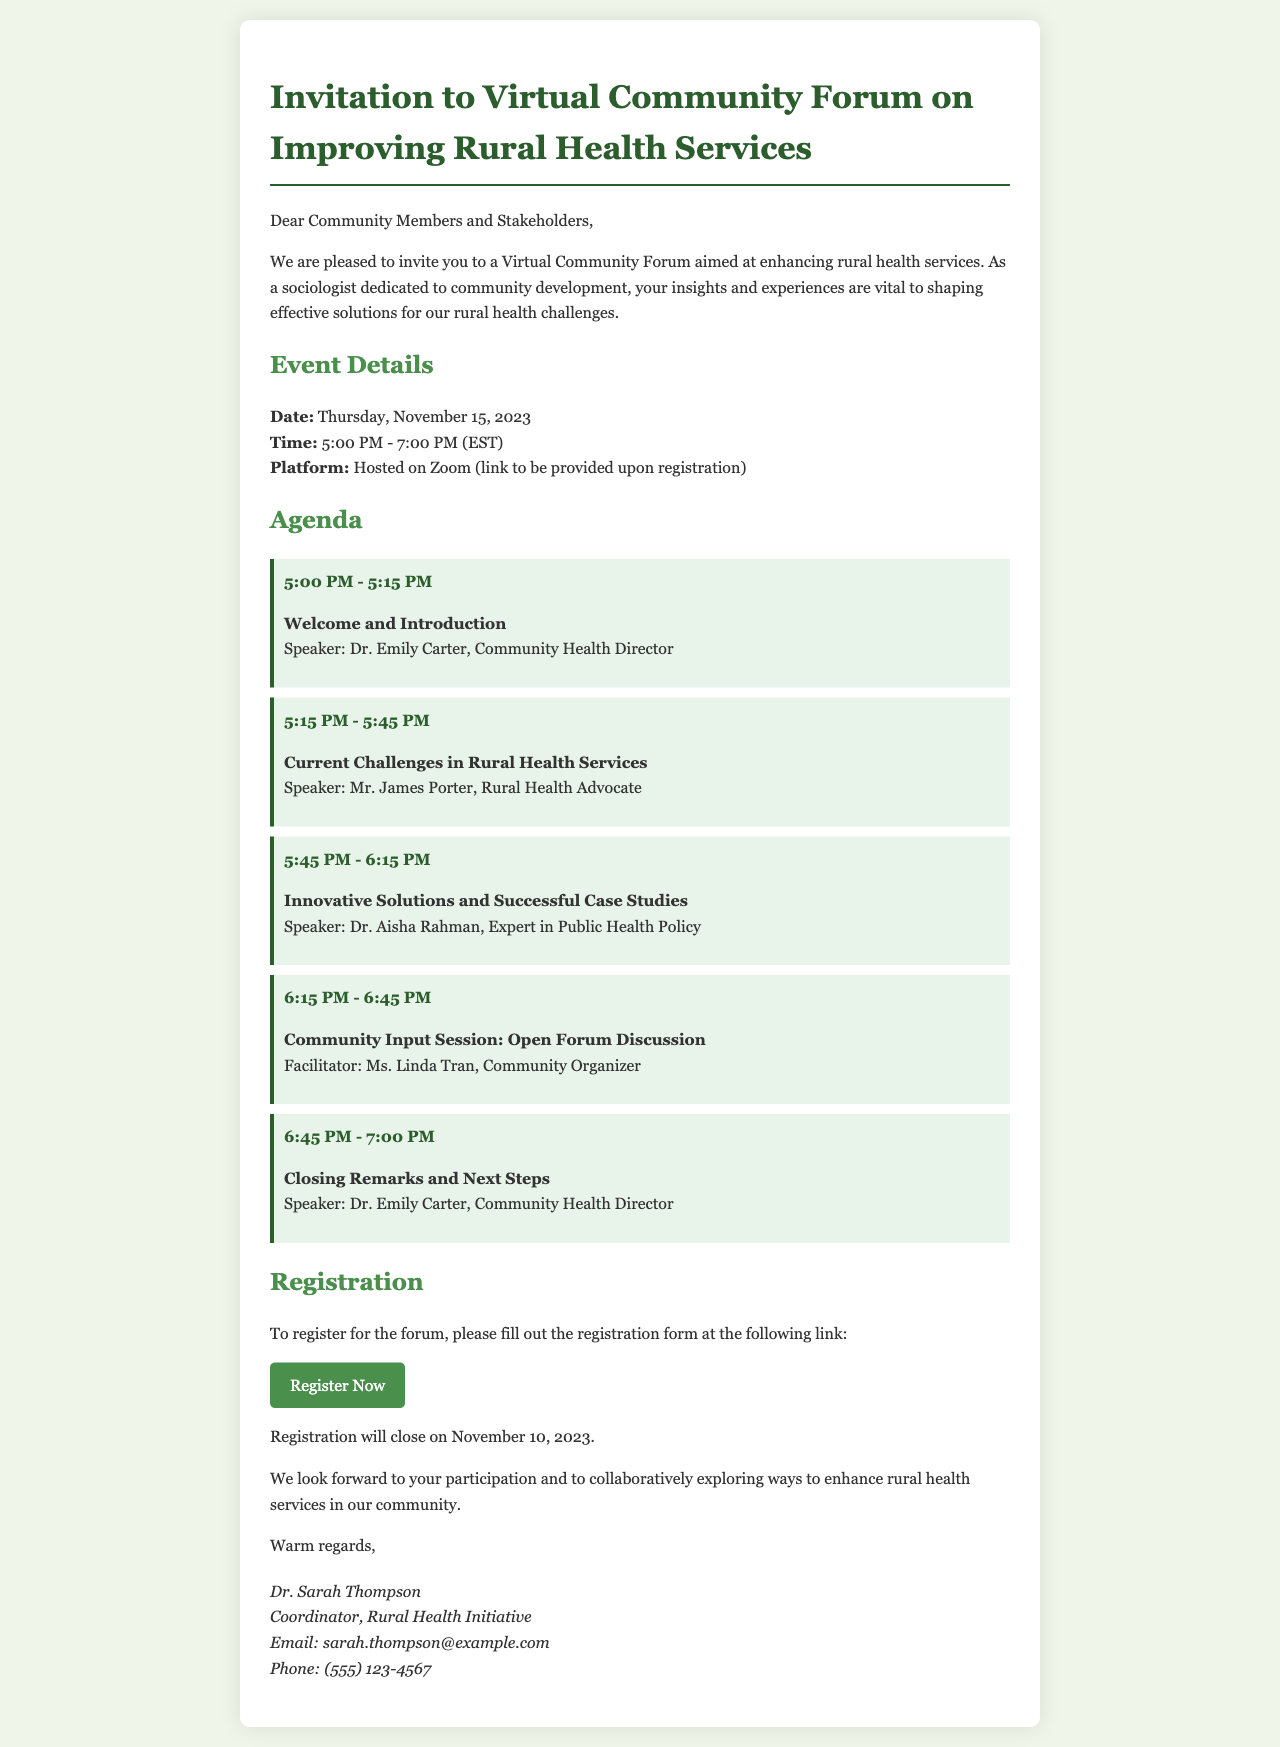What is the date of the virtual community forum? The date of the forum is mentioned clearly in the document as Thursday, November 15, 2023.
Answer: Thursday, November 15, 2023 What time does the forum start? The start time of the forum is specified as 5:00 PM in the event details section.
Answer: 5:00 PM Who is the speaker for the closing remarks? The document lists Dr. Emily Carter as the speaker for the closing remarks section.
Answer: Dr. Emily Carter What is the last date for registration? The registration closing date is explicitly stated as November 10, 2023.
Answer: November 10, 2023 What platform will the forum be hosted on? The platform for the forum is mentioned as Zoom in the event details.
Answer: Zoom What is the total duration of the forum? The forum runs from 5:00 PM to 7:00 PM, which is a total of 2 hours.
Answer: 2 hours What topic is discussed from 5:15 PM to 5:45 PM? This time slot covers "Current Challenges in Rural Health Services," as indicated in the agenda.
Answer: Current Challenges in Rural Health Services Who is facilitating the community input session? The facilitator is specified as Ms. Linda Tran in the agenda section.
Answer: Ms. Linda Tran 